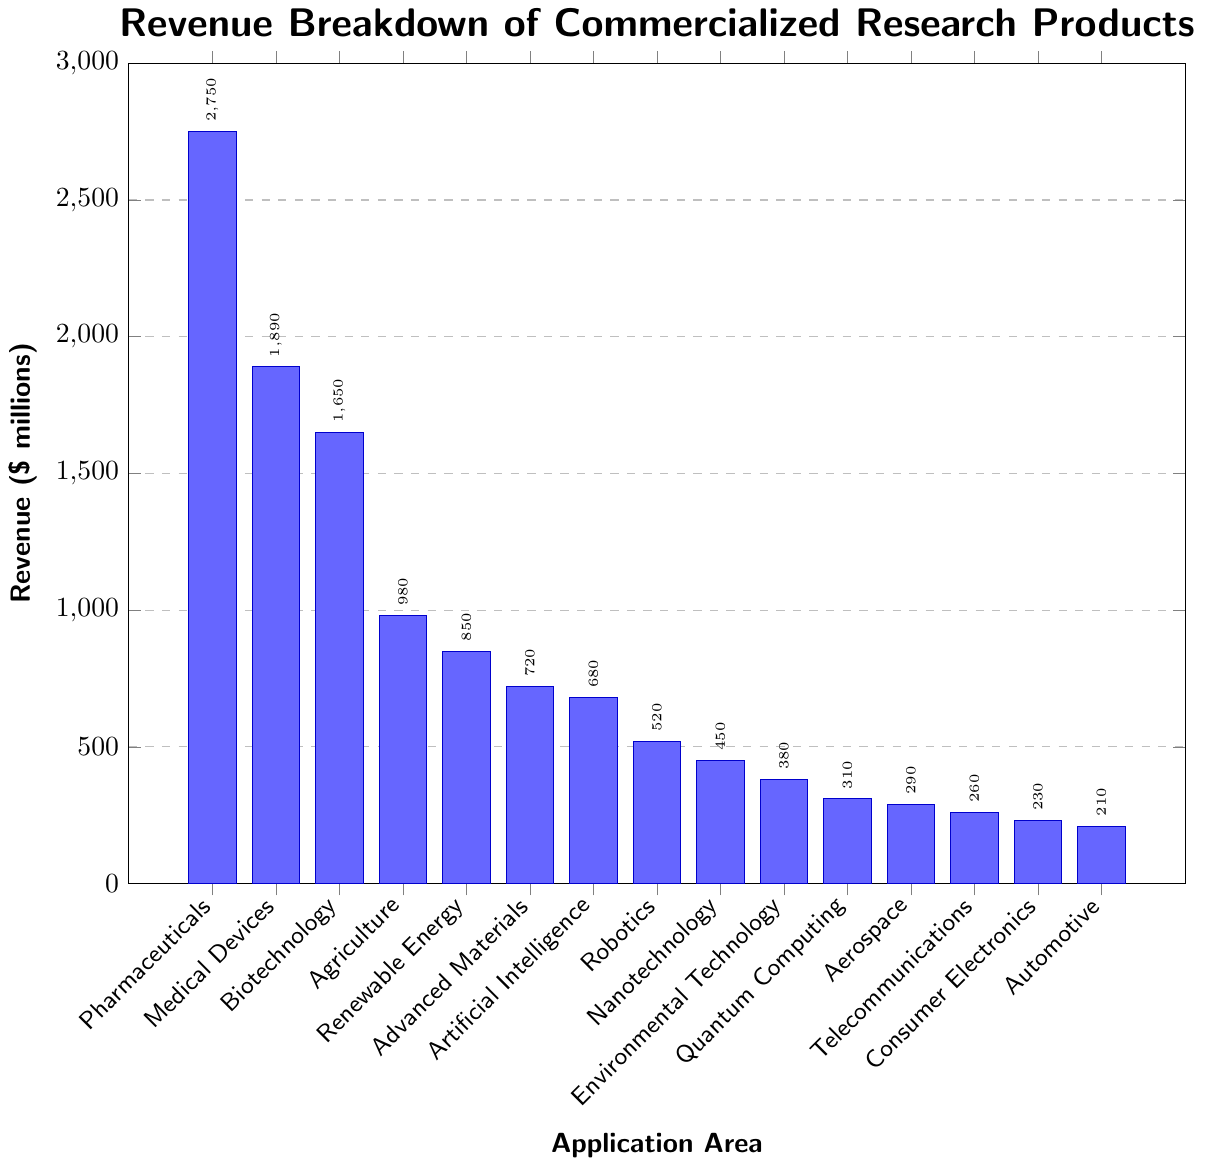What's the revenue generated by Pharmaceuticals? The height of the bar representing Pharmaceuticals corresponds to a revenue of $2750 million.
Answer: $2750 million Which application area has the highest revenue, and what is its value? By comparing the heights of all the bars, the Pharmaceuticals application area has the highest revenue, with a value of $2750 million.
Answer: Pharmaceuticals, $2750 million How much more revenue does Medical Devices generate compared to Biotechnology? The revenue for Medical Devices is $1890 million, and for Biotechnology, it is $1650 million. The difference is $1890 million - $1650 million = $240 million.
Answer: $240 million List the top three application areas by revenue. The top three application areas by revenue are Pharmaceuticals ($2750 million), Medical Devices ($1890 million), and Biotechnology ($1650 million).
Answer: Pharmaceuticals, Medical Devices, Biotechnology What's the combined revenue of Renewable Energy, Advanced Materials, and Artificial Intelligence? The revenue for Renewable Energy is $850 million, for Advanced Materials is $720 million, and for Artificial Intelligence is $680 million. The combined revenue is $850 million + $720 million + $680 million = $2250 million.
Answer: $2250 million Which application area has the lowest revenue, and what is its value? By comparing the heights of all the bars, the Automotive application area has the lowest revenue, with a value of $210 million.
Answer: Automotive, $210 million How does the revenue of Nanotechnology compare with Environmental Technology? The revenue for Nanotechnology is $450 million, while for Environmental Technology, it is $380 million. Nanotechnology has a revenue that is $450 million - $380 million = $70 million higher than Environmental Technology.
Answer: $70 million higher What is the median revenue of all the application areas? To find the median, list out the revenue values in ascending order: $210, $230, $260, $290, $310, $380, $450, $520, $680, $720, $850, $980, $1650, $1890, $2750. The middle value (8th in this sorted list) is $520 million.
Answer: $520 million Compare the combined revenue of Agriculture, Renewable Energy, and Advanced Materials with that of Pharmaceuticals. The combined revenue of Agriculture ($980 million), Renewable Energy ($850 million), and Advanced Materials ($720 million) is $980 million + $850 million + $720 million = $2550 million. The revenue of Pharmaceuticals alone is $2750 million. Pharmaceuticals' revenue is $2750 million - $2550 million = $200 million higher.
Answer: $200 million higher What proportion of the total revenue is generated by the top five application areas? The top five application areas by revenue are Pharmaceuticals ($2750 million), Medical Devices ($1890 million), Biotechnology ($1650 million), Agriculture ($980 million), and Renewable Energy ($850 million). The total revenue is $2750 million + $1890 million + $1650 million + $980 million + $850 million = $9120 million. The total revenue for all application areas is $16320 million (sum of all data points). The proportion is $9120 million / $16320 million ≈ 0.559 or 55.9%.
Answer: 55.9% 